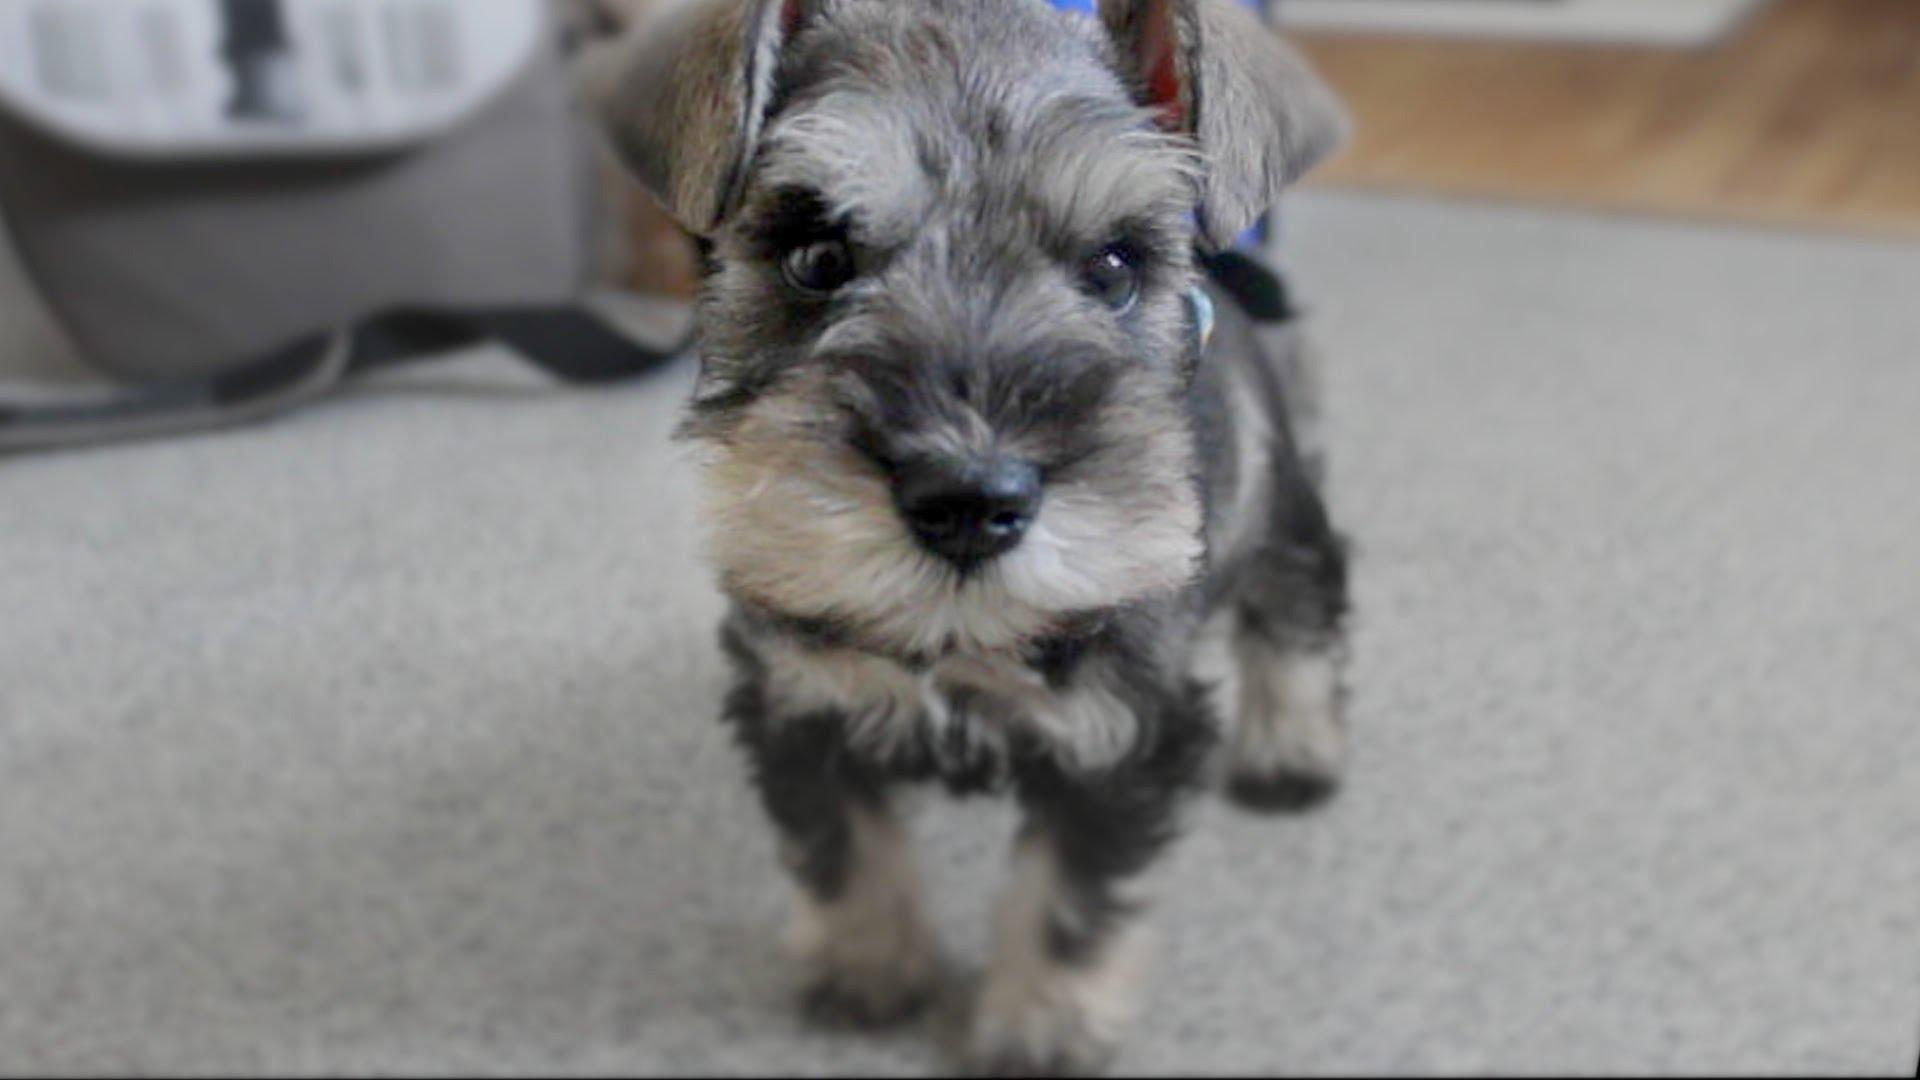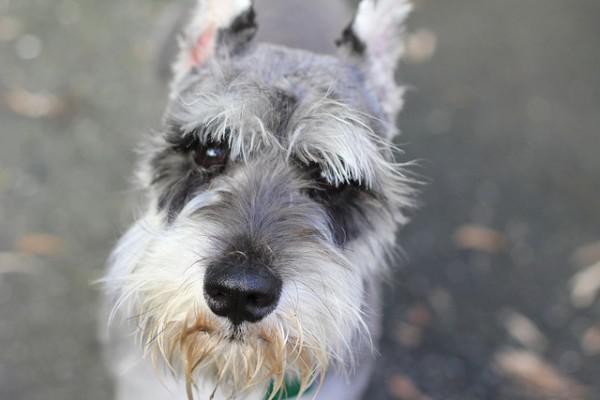The first image is the image on the left, the second image is the image on the right. Analyze the images presented: Is the assertion "One of the dogs is sitting on a wooden floor." valid? Answer yes or no. No. The first image is the image on the left, the second image is the image on the right. Examine the images to the left and right. Is the description "An image shows a black-faced schnauzer with something blue by its front paws." accurate? Answer yes or no. No. 